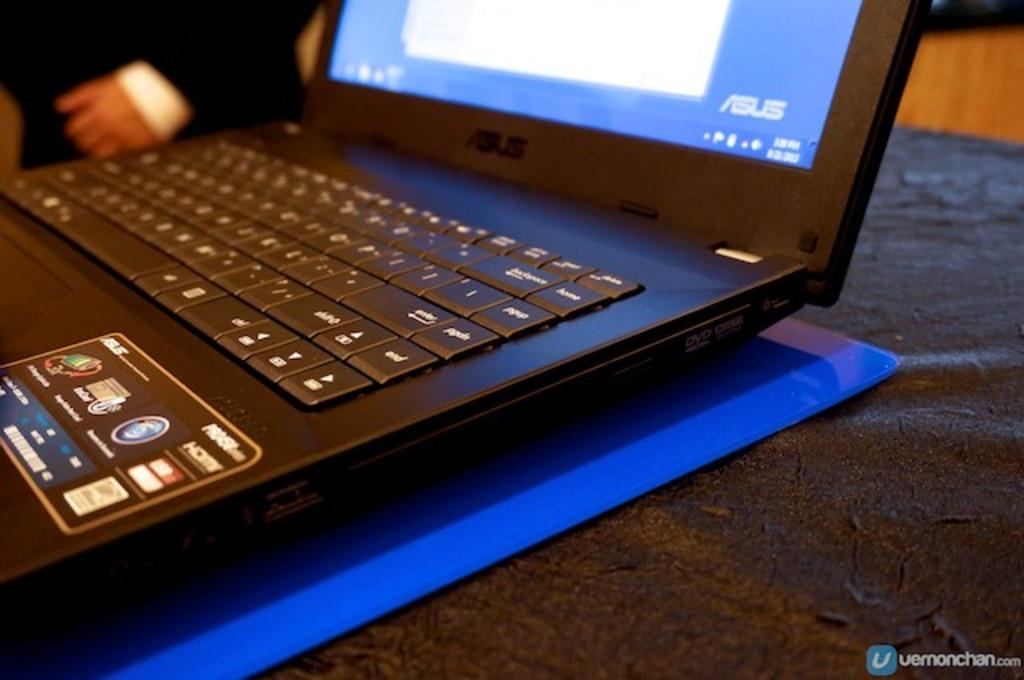What is the main object in the center of the image? There is a laptop in the center of the image. What is the object located at the bottom of the image? There is a table at the bottom of the image. Can you describe the person in the background of the image? There is a person standing in the background of the image. What else can be seen in the background of the image? There is an unspecified object in the background of the image. What type of mailbox is visible in the image? There is no mailbox present in the image. What memory is the person in the background celebrating in the image? There is no indication of a specific memory or event being celebrated in the image. 